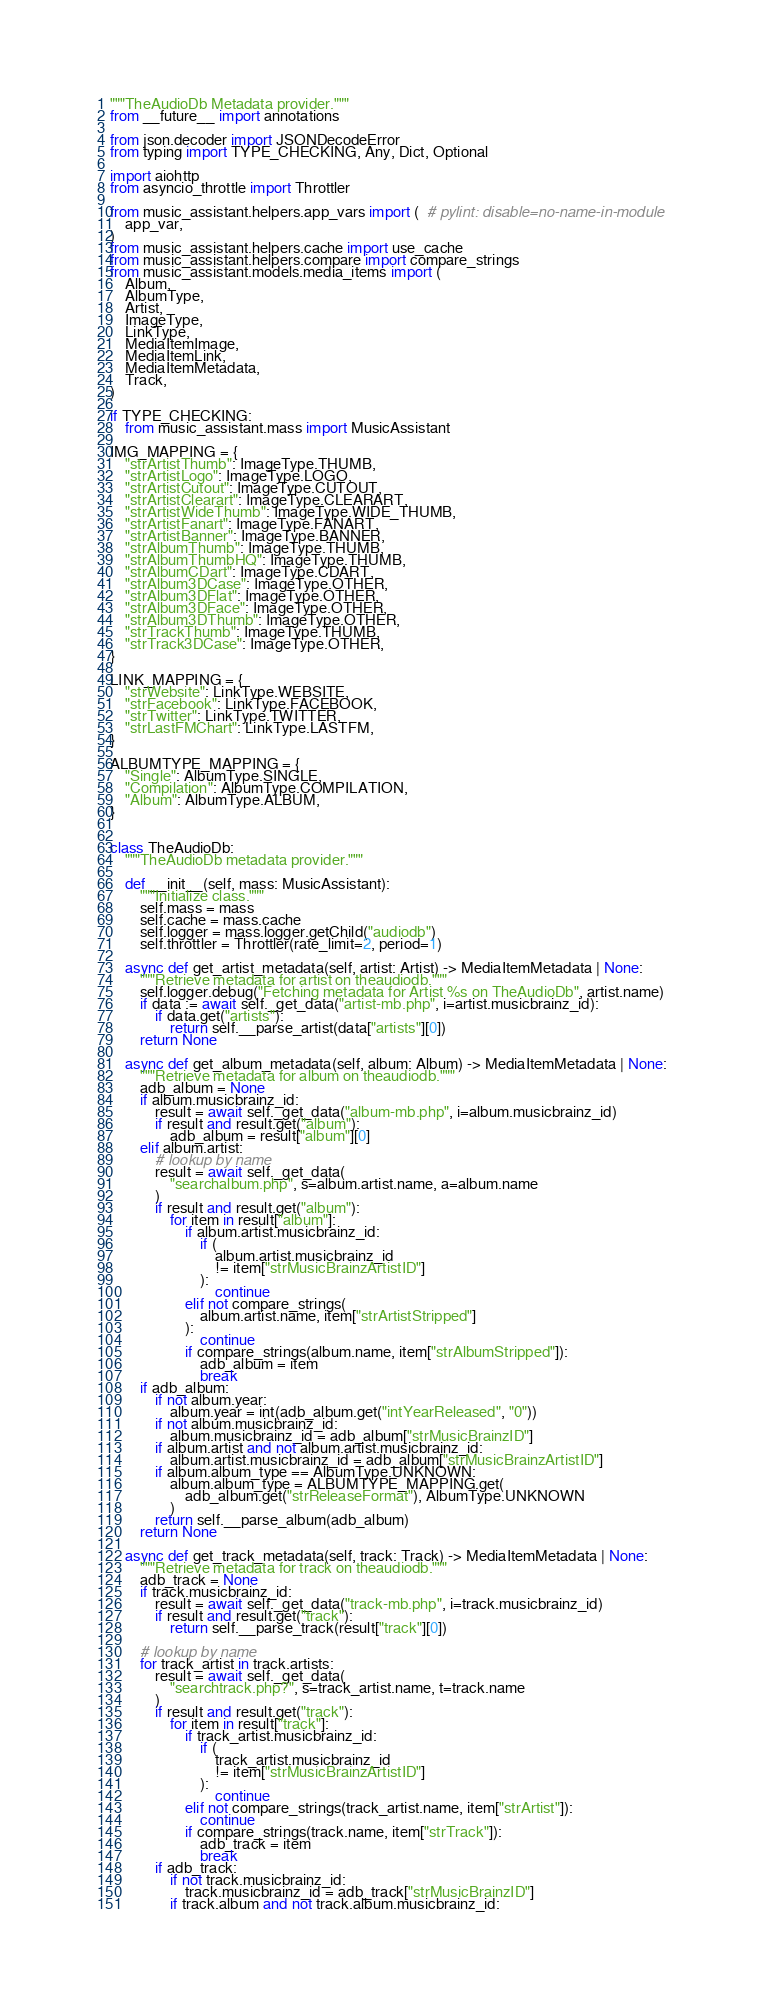Convert code to text. <code><loc_0><loc_0><loc_500><loc_500><_Python_>"""TheAudioDb Metadata provider."""
from __future__ import annotations

from json.decoder import JSONDecodeError
from typing import TYPE_CHECKING, Any, Dict, Optional

import aiohttp
from asyncio_throttle import Throttler

from music_assistant.helpers.app_vars import (  # pylint: disable=no-name-in-module
    app_var,
)
from music_assistant.helpers.cache import use_cache
from music_assistant.helpers.compare import compare_strings
from music_assistant.models.media_items import (
    Album,
    AlbumType,
    Artist,
    ImageType,
    LinkType,
    MediaItemImage,
    MediaItemLink,
    MediaItemMetadata,
    Track,
)

if TYPE_CHECKING:
    from music_assistant.mass import MusicAssistant

IMG_MAPPING = {
    "strArtistThumb": ImageType.THUMB,
    "strArtistLogo": ImageType.LOGO,
    "strArtistCutout": ImageType.CUTOUT,
    "strArtistClearart": ImageType.CLEARART,
    "strArtistWideThumb": ImageType.WIDE_THUMB,
    "strArtistFanart": ImageType.FANART,
    "strArtistBanner": ImageType.BANNER,
    "strAlbumThumb": ImageType.THUMB,
    "strAlbumThumbHQ": ImageType.THUMB,
    "strAlbumCDart": ImageType.CDART,
    "strAlbum3DCase": ImageType.OTHER,
    "strAlbum3DFlat": ImageType.OTHER,
    "strAlbum3DFace": ImageType.OTHER,
    "strAlbum3DThumb": ImageType.OTHER,
    "strTrackThumb": ImageType.THUMB,
    "strTrack3DCase": ImageType.OTHER,
}

LINK_MAPPING = {
    "strWebsite": LinkType.WEBSITE,
    "strFacebook": LinkType.FACEBOOK,
    "strTwitter": LinkType.TWITTER,
    "strLastFMChart": LinkType.LASTFM,
}

ALBUMTYPE_MAPPING = {
    "Single": AlbumType.SINGLE,
    "Compilation": AlbumType.COMPILATION,
    "Album": AlbumType.ALBUM,
}


class TheAudioDb:
    """TheAudioDb metadata provider."""

    def __init__(self, mass: MusicAssistant):
        """Initialize class."""
        self.mass = mass
        self.cache = mass.cache
        self.logger = mass.logger.getChild("audiodb")
        self.throttler = Throttler(rate_limit=2, period=1)

    async def get_artist_metadata(self, artist: Artist) -> MediaItemMetadata | None:
        """Retrieve metadata for artist on theaudiodb."""
        self.logger.debug("Fetching metadata for Artist %s on TheAudioDb", artist.name)
        if data := await self._get_data("artist-mb.php", i=artist.musicbrainz_id):
            if data.get("artists"):
                return self.__parse_artist(data["artists"][0])
        return None

    async def get_album_metadata(self, album: Album) -> MediaItemMetadata | None:
        """Retrieve metadata for album on theaudiodb."""
        adb_album = None
        if album.musicbrainz_id:
            result = await self._get_data("album-mb.php", i=album.musicbrainz_id)
            if result and result.get("album"):
                adb_album = result["album"][0]
        elif album.artist:
            # lookup by name
            result = await self._get_data(
                "searchalbum.php", s=album.artist.name, a=album.name
            )
            if result and result.get("album"):
                for item in result["album"]:
                    if album.artist.musicbrainz_id:
                        if (
                            album.artist.musicbrainz_id
                            != item["strMusicBrainzArtistID"]
                        ):
                            continue
                    elif not compare_strings(
                        album.artist.name, item["strArtistStripped"]
                    ):
                        continue
                    if compare_strings(album.name, item["strAlbumStripped"]):
                        adb_album = item
                        break
        if adb_album:
            if not album.year:
                album.year = int(adb_album.get("intYearReleased", "0"))
            if not album.musicbrainz_id:
                album.musicbrainz_id = adb_album["strMusicBrainzID"]
            if album.artist and not album.artist.musicbrainz_id:
                album.artist.musicbrainz_id = adb_album["strMusicBrainzArtistID"]
            if album.album_type == AlbumType.UNKNOWN:
                album.album_type = ALBUMTYPE_MAPPING.get(
                    adb_album.get("strReleaseFormat"), AlbumType.UNKNOWN
                )
            return self.__parse_album(adb_album)
        return None

    async def get_track_metadata(self, track: Track) -> MediaItemMetadata | None:
        """Retrieve metadata for track on theaudiodb."""
        adb_track = None
        if track.musicbrainz_id:
            result = await self._get_data("track-mb.php", i=track.musicbrainz_id)
            if result and result.get("track"):
                return self.__parse_track(result["track"][0])

        # lookup by name
        for track_artist in track.artists:
            result = await self._get_data(
                "searchtrack.php?", s=track_artist.name, t=track.name
            )
            if result and result.get("track"):
                for item in result["track"]:
                    if track_artist.musicbrainz_id:
                        if (
                            track_artist.musicbrainz_id
                            != item["strMusicBrainzArtistID"]
                        ):
                            continue
                    elif not compare_strings(track_artist.name, item["strArtist"]):
                        continue
                    if compare_strings(track.name, item["strTrack"]):
                        adb_track = item
                        break
            if adb_track:
                if not track.musicbrainz_id:
                    track.musicbrainz_id = adb_track["strMusicBrainzID"]
                if track.album and not track.album.musicbrainz_id:</code> 